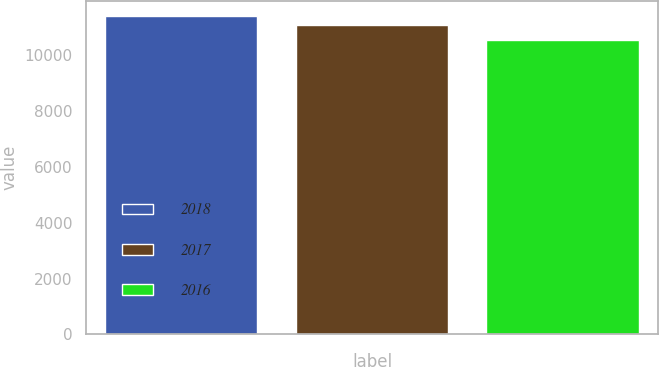Convert chart. <chart><loc_0><loc_0><loc_500><loc_500><bar_chart><fcel>2018<fcel>2017<fcel>2016<nl><fcel>11374<fcel>11065<fcel>10541<nl></chart> 